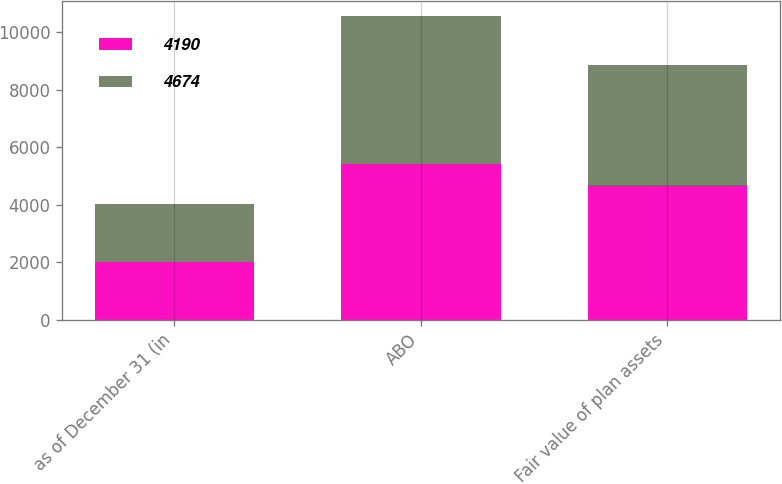Convert chart. <chart><loc_0><loc_0><loc_500><loc_500><stacked_bar_chart><ecel><fcel>as of December 31 (in<fcel>ABO<fcel>Fair value of plan assets<nl><fcel>4190<fcel>2017<fcel>5398<fcel>4674<nl><fcel>4674<fcel>2016<fcel>5153<fcel>4190<nl></chart> 